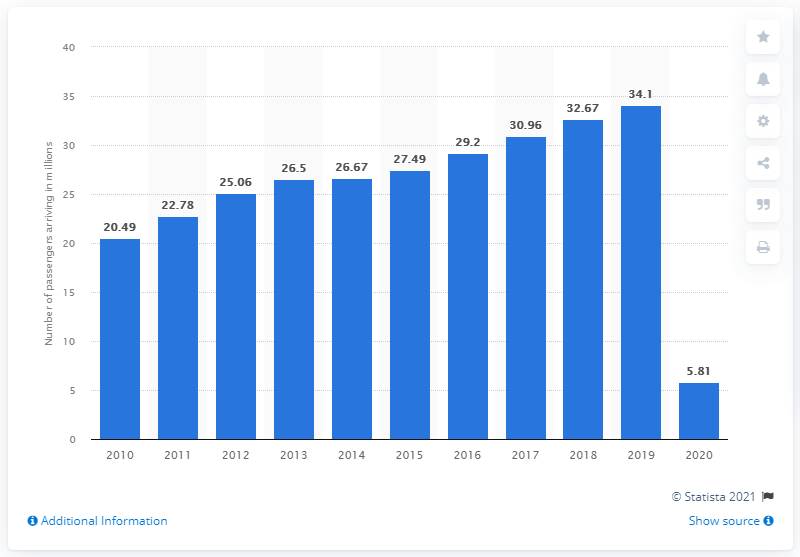Outline some significant characteristics in this image. In 2020, a total of 5,810,000 people arrived at Singaporean Changi Airport. In 2020, more than 5.81 million people arrived at Singapore's Changi Airport. 